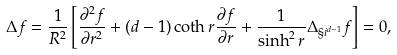Convert formula to latex. <formula><loc_0><loc_0><loc_500><loc_500>\Delta f = \frac { 1 } { R ^ { 2 } } \left [ \frac { \partial ^ { 2 } f } { \partial r ^ { 2 } } + ( d - 1 ) \coth r \frac { \partial f } { \partial r } + \frac { 1 } { \sinh ^ { 2 } r } \Delta _ { \S i ^ { d - 1 } } f \right ] = 0 ,</formula> 